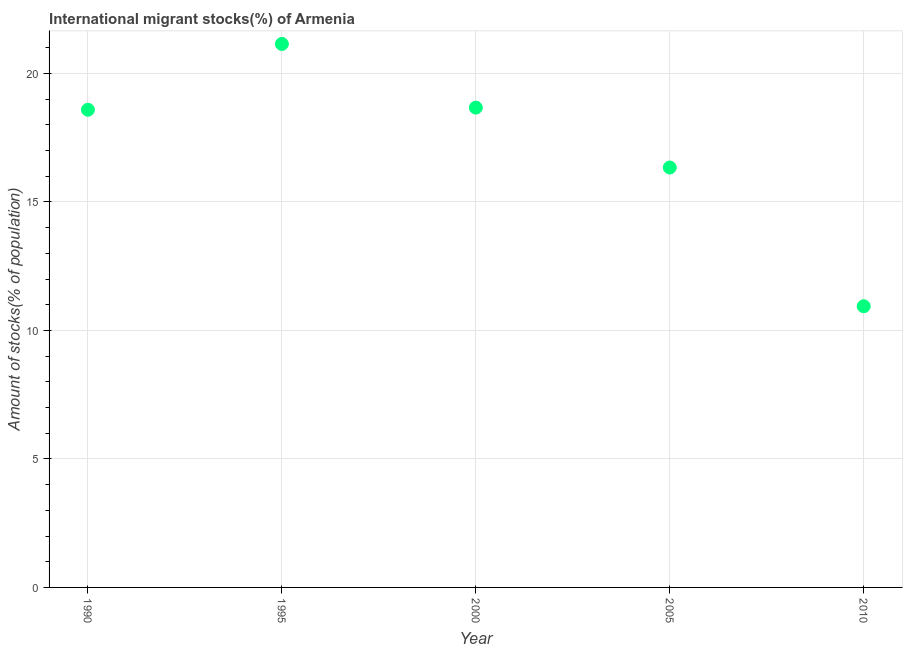What is the number of international migrant stocks in 1990?
Offer a very short reply. 18.59. Across all years, what is the maximum number of international migrant stocks?
Provide a short and direct response. 21.15. Across all years, what is the minimum number of international migrant stocks?
Give a very brief answer. 10.94. In which year was the number of international migrant stocks minimum?
Keep it short and to the point. 2010. What is the sum of the number of international migrant stocks?
Your response must be concise. 85.68. What is the difference between the number of international migrant stocks in 1995 and 2000?
Keep it short and to the point. 2.48. What is the average number of international migrant stocks per year?
Offer a very short reply. 17.14. What is the median number of international migrant stocks?
Your answer should be compact. 18.59. What is the ratio of the number of international migrant stocks in 2000 to that in 2005?
Offer a terse response. 1.14. What is the difference between the highest and the second highest number of international migrant stocks?
Provide a succinct answer. 2.48. What is the difference between the highest and the lowest number of international migrant stocks?
Provide a succinct answer. 10.21. In how many years, is the number of international migrant stocks greater than the average number of international migrant stocks taken over all years?
Provide a short and direct response. 3. How many dotlines are there?
Your answer should be very brief. 1. How many years are there in the graph?
Offer a terse response. 5. Are the values on the major ticks of Y-axis written in scientific E-notation?
Offer a terse response. No. Does the graph contain grids?
Offer a terse response. Yes. What is the title of the graph?
Offer a very short reply. International migrant stocks(%) of Armenia. What is the label or title of the X-axis?
Keep it short and to the point. Year. What is the label or title of the Y-axis?
Offer a terse response. Amount of stocks(% of population). What is the Amount of stocks(% of population) in 1990?
Your response must be concise. 18.59. What is the Amount of stocks(% of population) in 1995?
Offer a terse response. 21.15. What is the Amount of stocks(% of population) in 2000?
Your answer should be compact. 18.67. What is the Amount of stocks(% of population) in 2005?
Offer a very short reply. 16.34. What is the Amount of stocks(% of population) in 2010?
Keep it short and to the point. 10.94. What is the difference between the Amount of stocks(% of population) in 1990 and 1995?
Give a very brief answer. -2.56. What is the difference between the Amount of stocks(% of population) in 1990 and 2000?
Make the answer very short. -0.08. What is the difference between the Amount of stocks(% of population) in 1990 and 2005?
Give a very brief answer. 2.25. What is the difference between the Amount of stocks(% of population) in 1990 and 2010?
Offer a terse response. 7.65. What is the difference between the Amount of stocks(% of population) in 1995 and 2000?
Provide a succinct answer. 2.48. What is the difference between the Amount of stocks(% of population) in 1995 and 2005?
Offer a very short reply. 4.81. What is the difference between the Amount of stocks(% of population) in 1995 and 2010?
Make the answer very short. 10.21. What is the difference between the Amount of stocks(% of population) in 2000 and 2005?
Your answer should be compact. 2.33. What is the difference between the Amount of stocks(% of population) in 2000 and 2010?
Provide a short and direct response. 7.73. What is the difference between the Amount of stocks(% of population) in 2005 and 2010?
Your answer should be compact. 5.4. What is the ratio of the Amount of stocks(% of population) in 1990 to that in 1995?
Offer a terse response. 0.88. What is the ratio of the Amount of stocks(% of population) in 1990 to that in 2000?
Ensure brevity in your answer.  1. What is the ratio of the Amount of stocks(% of population) in 1990 to that in 2005?
Your answer should be compact. 1.14. What is the ratio of the Amount of stocks(% of population) in 1990 to that in 2010?
Provide a short and direct response. 1.7. What is the ratio of the Amount of stocks(% of population) in 1995 to that in 2000?
Provide a short and direct response. 1.13. What is the ratio of the Amount of stocks(% of population) in 1995 to that in 2005?
Your answer should be compact. 1.29. What is the ratio of the Amount of stocks(% of population) in 1995 to that in 2010?
Provide a succinct answer. 1.93. What is the ratio of the Amount of stocks(% of population) in 2000 to that in 2005?
Keep it short and to the point. 1.14. What is the ratio of the Amount of stocks(% of population) in 2000 to that in 2010?
Make the answer very short. 1.71. What is the ratio of the Amount of stocks(% of population) in 2005 to that in 2010?
Provide a short and direct response. 1.49. 